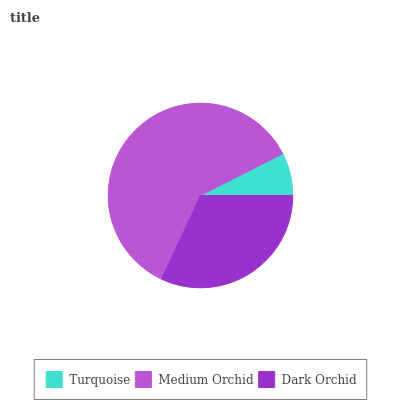Is Turquoise the minimum?
Answer yes or no. Yes. Is Medium Orchid the maximum?
Answer yes or no. Yes. Is Dark Orchid the minimum?
Answer yes or no. No. Is Dark Orchid the maximum?
Answer yes or no. No. Is Medium Orchid greater than Dark Orchid?
Answer yes or no. Yes. Is Dark Orchid less than Medium Orchid?
Answer yes or no. Yes. Is Dark Orchid greater than Medium Orchid?
Answer yes or no. No. Is Medium Orchid less than Dark Orchid?
Answer yes or no. No. Is Dark Orchid the high median?
Answer yes or no. Yes. Is Dark Orchid the low median?
Answer yes or no. Yes. Is Medium Orchid the high median?
Answer yes or no. No. Is Turquoise the low median?
Answer yes or no. No. 